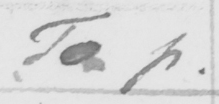What does this handwritten line say? To p . 